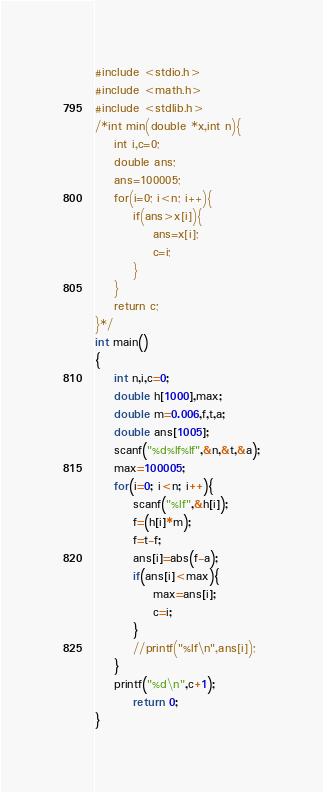<code> <loc_0><loc_0><loc_500><loc_500><_C_>#include <stdio.h>
#include <math.h>
#include <stdlib.h>
/*int min(double *x,int n){
	int i,c=0;
	double ans;
	ans=100005;
	for(i=0; i<n; i++){
		if(ans>x[i]){
			ans=x[i];
			c=i;
		}
	}
	return c;
}*/
int main()
{
	int n,i,c=0;
	double h[1000],max;
	double m=0.006,f,t,a;
	double ans[1005];
	scanf("%d%lf%lf",&n,&t,&a);
	max=100005;
	for(i=0; i<n; i++){
		scanf("%lf",&h[i]);
		f=(h[i]*m);
		f=t-f;
		ans[i]=abs(f-a);
		if(ans[i]<max){
			max=ans[i];
			c=i;
		}
		//printf("%lf\n",ans[i]);
	}
	printf("%d\n",c+1);
        return 0;
}
</code> 